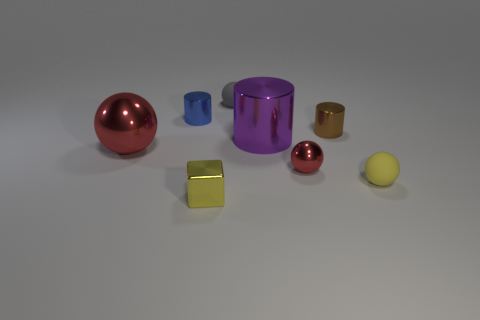Add 2 large red metal spheres. How many objects exist? 10 Subtract all cubes. How many objects are left? 7 Add 4 blue matte cylinders. How many blue matte cylinders exist? 4 Subtract 1 yellow cubes. How many objects are left? 7 Subtract all large blue shiny things. Subtract all large red spheres. How many objects are left? 7 Add 6 small yellow spheres. How many small yellow spheres are left? 7 